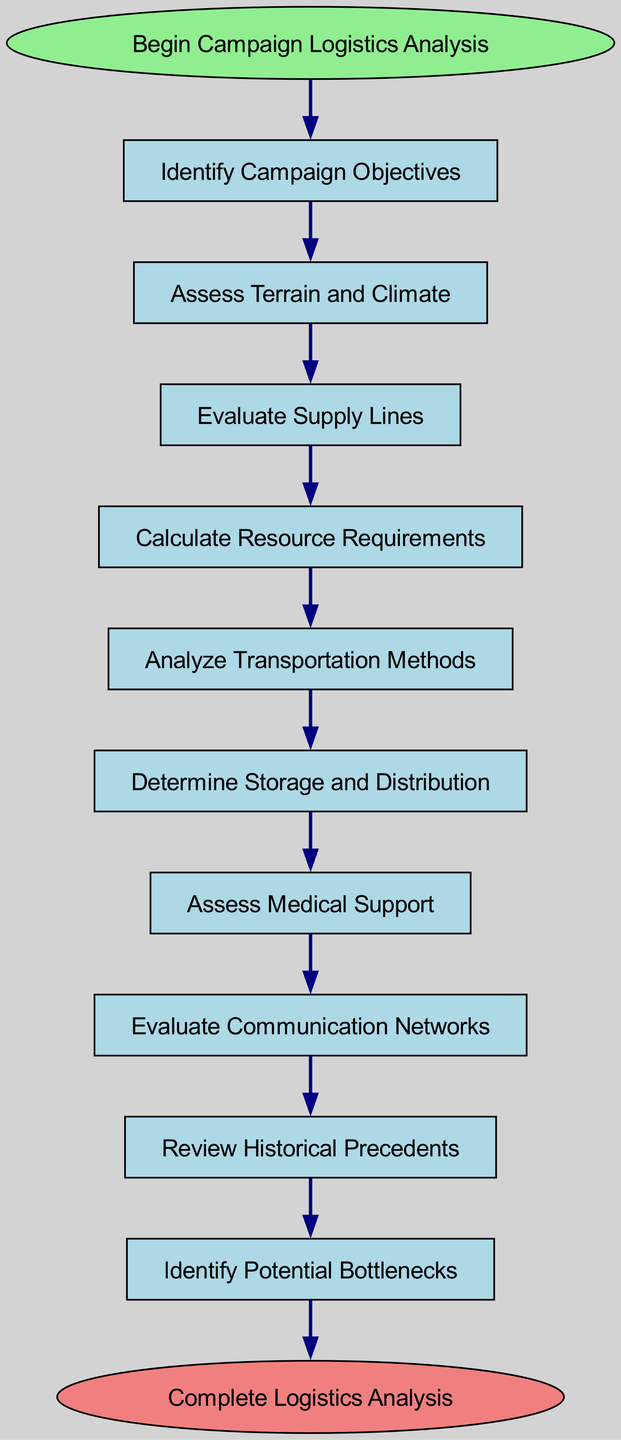What is the first step in the campaign logistics analysis? The diagram indicates that the first step is labeled "Identify Campaign Objectives," which is directly following the start node.
Answer: Identify Campaign Objectives How many total steps are there in the analysis process? By counting each of the individual steps listed in the diagram, there are a total of ten steps outlined from "Identify Campaign Objectives" to "Identify Potential Bottlenecks."
Answer: Ten Which step follows "Evaluate Supply Lines"? The immediate next step after "Evaluate Supply Lines," according to the flow of the diagram, is "Calculate Resource Requirements."
Answer: Calculate Resource Requirements What is the last step before completing the logistics analysis? Observing the final sequence in the diagram, the last step before reaching the end node is "Develop Contingency Plans."
Answer: Develop Contingency Plans Which two steps are connected by an edge? The steps that are connected by an edge are "Assess Medical Support" and "Evaluate Communication Networks," as shown in the sequential flow from one step to the next.
Answer: Assess Medical Support and Evaluate Communication Networks What do you assess after determining storage and distribution? Following "Determine Storage and Distribution," the next step in the flow chart is to "Assess Medical Support."
Answer: Assess Medical Support Which step involves preparing for unexpected issues? The final step "Develop Contingency Plans" is designated for preparing for potential unexpected issues that could arise during the campaign logistics.
Answer: Develop Contingency Plans What precedes the assessment of communication networks? The step that comes right before "Evaluate Communication Networks" in the flow is "Assess Medical Support," demonstrating the order of analysis steps.
Answer: Assess Medical Support How many nodes are there from start to end, inclusive? Counting both the start and end nodes along with the 10 steps, there are a total of 12 nodes in the complete diagram.
Answer: Twelve 